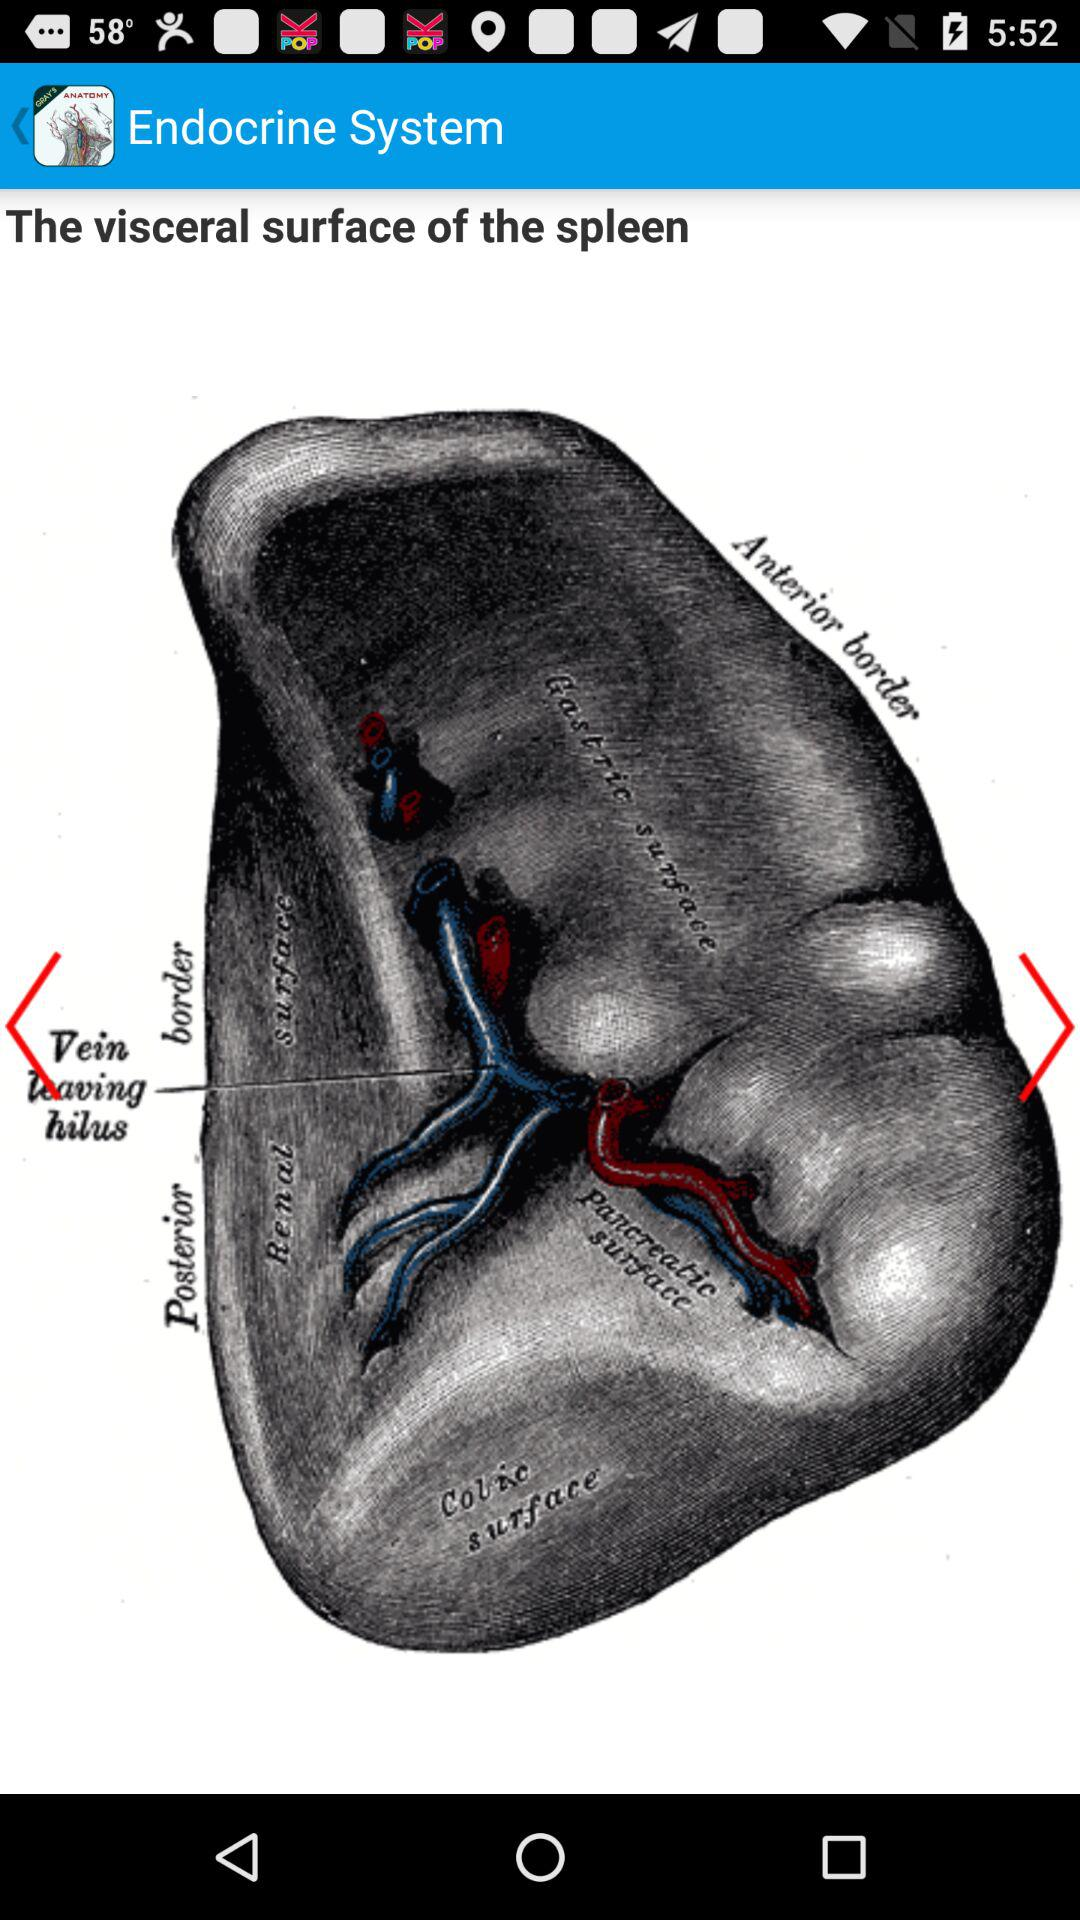What is the application name? The application name is "Endocrine System". 